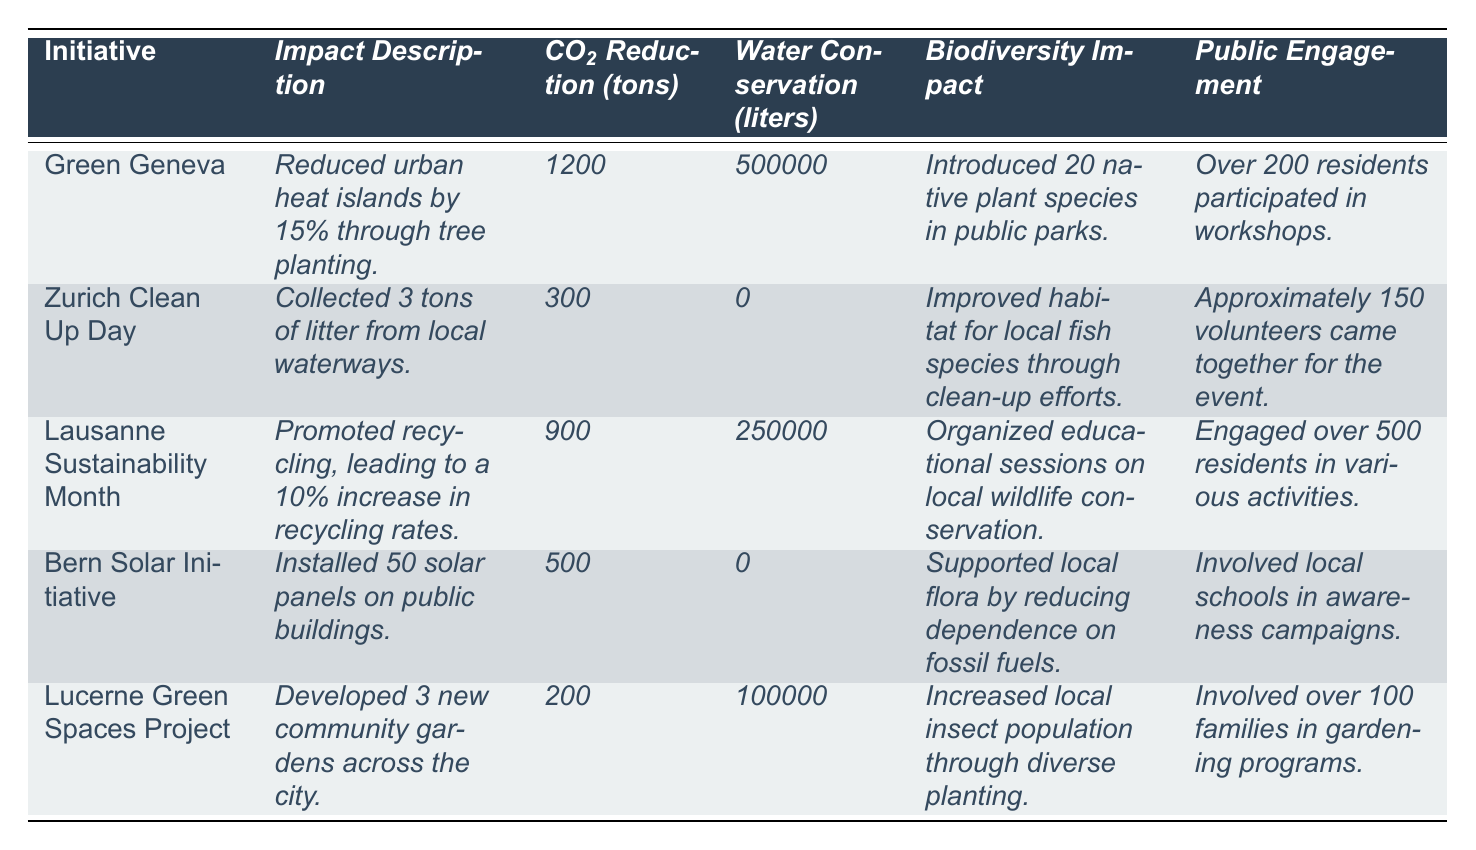What is the total CO2 reduction achieved by all initiatives? To find the total CO2 reduction, we add the CO2 reduction values of each initiative: 1200 + 300 + 900 + 500 + 200 = 3100 tons.
Answer: 3100 tons How many native plant species were introduced by the Green Geneva initiative? According to the table, Green Geneva introduced 20 native plant species in public parks.
Answer: 20 species Did the Zurich Clean Up Day contribute to water conservation? The table states that Zurich Clean Up Day had a water conservation value of 0 liters, indicating it did not contribute to water conservation.
Answer: No Which initiative involved the highest public engagement? We compare the public engagement figures for each initiative: Green Geneva (over 200), Zurich Clean Up Day (approximately 150), Lausanne Sustainability Month (over 500), Bern Solar Initiative (involved local schools), and Lucerne Green Spaces Project (over 100). Lausanne Sustainability Month had the highest engagement with over 500 residents.
Answer: Lausanne Sustainability Month What is the average amount of CO2 reduction per initiative? The total CO2 reduction is 3100 tons, and there are 5 initiatives. To find the average, we divide total CO2 reduction by the number of initiatives: 3100 / 5 = 620 tons.
Answer: 620 tons How many initiatives had a water conservation value greater than 0 liters? Reviewing the table, Green Geneva (500,000 liters), Lausanne Sustainability Month (250,000 liters), and Lucerne Green Spaces Project (100,000 liters) have water conservation values greater than 0. The initiatives that meet this criteria are three.
Answer: 3 initiatives Which initiative focused on biodiversity education? The initiatives that mentioned biodiversity education include Lausanne Sustainability Month (educational sessions on local wildlife conservation) and Bern Solar Initiative (supported local flora). However, only Lausanne Sustainability Month explicitly states it organized educational sessions.
Answer: Lausanne Sustainability Month What is the total water conservation achieved by the initiatives? We sum the water conservation values: 500,000 + 0 + 250,000 + 0 + 100,000 = 850,000 liters.
Answer: 850,000 liters Which initiative collected litter, and how much was collected? According to the table, Zurich Clean Up Day collected 3 tons of litter from local waterways.
Answer: Zurich Clean Up Day, 3 tons Is there an initiative that reported no water conservation? Looking at the water conservation values, Zurich Clean Up Day and Bern Solar Initiative both reported a value of 0 liters. Thus, yes, there are initiatives with no water conservation reported.
Answer: Yes 